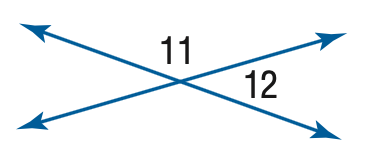Question: m \angle 11 = 4 x, m \angle 12 = 2 x - 6. Find the measure of \angle 11.
Choices:
A. 116
B. 118
C. 120
D. 124
Answer with the letter. Answer: D 